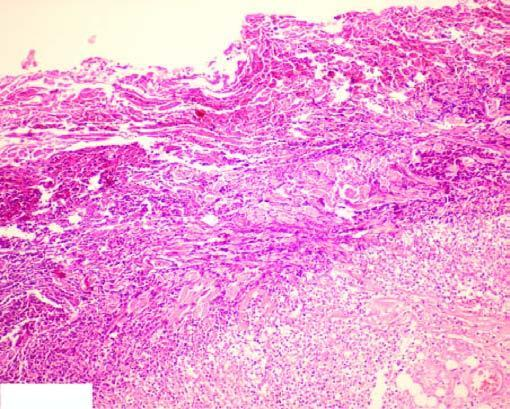re some macrophages seen at the periphery?
Answer the question using a single word or phrase. Yes 